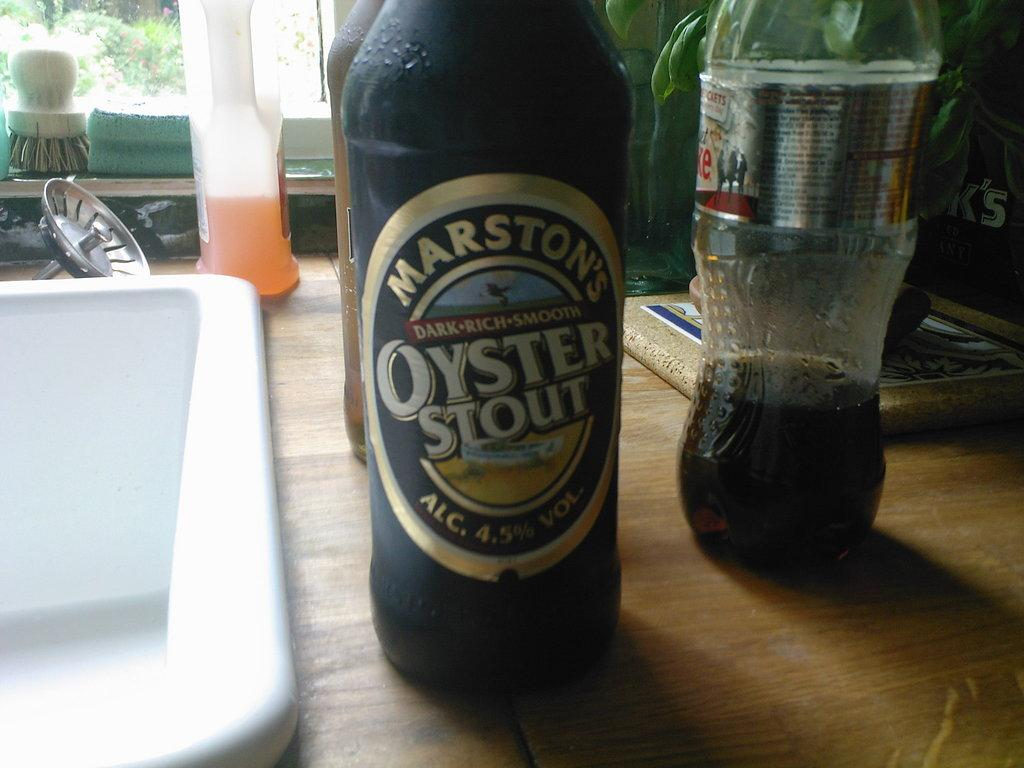<image>
Summarize the visual content of the image. Bottle of Oyster Stout next to a Coke bottle. 